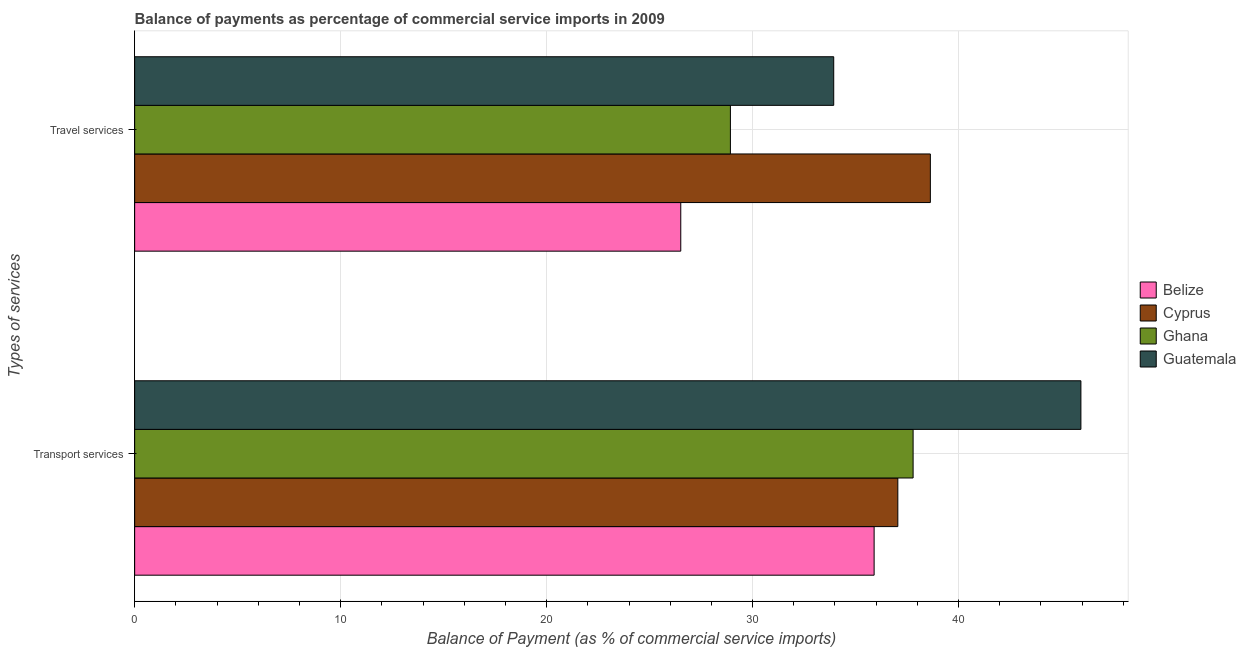Are the number of bars per tick equal to the number of legend labels?
Your answer should be very brief. Yes. Are the number of bars on each tick of the Y-axis equal?
Give a very brief answer. Yes. How many bars are there on the 1st tick from the bottom?
Offer a terse response. 4. What is the label of the 2nd group of bars from the top?
Your answer should be very brief. Transport services. What is the balance of payments of travel services in Guatemala?
Your response must be concise. 33.94. Across all countries, what is the maximum balance of payments of transport services?
Keep it short and to the point. 45.94. Across all countries, what is the minimum balance of payments of travel services?
Provide a succinct answer. 26.51. In which country was the balance of payments of transport services maximum?
Give a very brief answer. Guatemala. In which country was the balance of payments of transport services minimum?
Offer a very short reply. Belize. What is the total balance of payments of travel services in the graph?
Your response must be concise. 128.01. What is the difference between the balance of payments of transport services in Ghana and that in Belize?
Your answer should be very brief. 1.89. What is the difference between the balance of payments of travel services in Belize and the balance of payments of transport services in Cyprus?
Provide a succinct answer. -10.54. What is the average balance of payments of travel services per country?
Keep it short and to the point. 32. What is the difference between the balance of payments of transport services and balance of payments of travel services in Belize?
Your answer should be very brief. 9.39. What is the ratio of the balance of payments of travel services in Guatemala to that in Belize?
Your answer should be very brief. 1.28. What does the 3rd bar from the top in Transport services represents?
Keep it short and to the point. Cyprus. What does the 4th bar from the bottom in Travel services represents?
Offer a very short reply. Guatemala. Are all the bars in the graph horizontal?
Offer a terse response. Yes. How many countries are there in the graph?
Give a very brief answer. 4. Does the graph contain any zero values?
Your answer should be very brief. No. How many legend labels are there?
Ensure brevity in your answer.  4. What is the title of the graph?
Offer a terse response. Balance of payments as percentage of commercial service imports in 2009. Does "Afghanistan" appear as one of the legend labels in the graph?
Provide a short and direct response. No. What is the label or title of the X-axis?
Your response must be concise. Balance of Payment (as % of commercial service imports). What is the label or title of the Y-axis?
Your answer should be very brief. Types of services. What is the Balance of Payment (as % of commercial service imports) of Belize in Transport services?
Offer a very short reply. 35.9. What is the Balance of Payment (as % of commercial service imports) of Cyprus in Transport services?
Offer a terse response. 37.05. What is the Balance of Payment (as % of commercial service imports) of Ghana in Transport services?
Make the answer very short. 37.79. What is the Balance of Payment (as % of commercial service imports) of Guatemala in Transport services?
Keep it short and to the point. 45.94. What is the Balance of Payment (as % of commercial service imports) of Belize in Travel services?
Offer a terse response. 26.51. What is the Balance of Payment (as % of commercial service imports) of Cyprus in Travel services?
Provide a succinct answer. 38.63. What is the Balance of Payment (as % of commercial service imports) in Ghana in Travel services?
Your answer should be compact. 28.92. What is the Balance of Payment (as % of commercial service imports) in Guatemala in Travel services?
Offer a terse response. 33.94. Across all Types of services, what is the maximum Balance of Payment (as % of commercial service imports) of Belize?
Ensure brevity in your answer.  35.9. Across all Types of services, what is the maximum Balance of Payment (as % of commercial service imports) of Cyprus?
Offer a terse response. 38.63. Across all Types of services, what is the maximum Balance of Payment (as % of commercial service imports) of Ghana?
Provide a short and direct response. 37.79. Across all Types of services, what is the maximum Balance of Payment (as % of commercial service imports) in Guatemala?
Make the answer very short. 45.94. Across all Types of services, what is the minimum Balance of Payment (as % of commercial service imports) of Belize?
Make the answer very short. 26.51. Across all Types of services, what is the minimum Balance of Payment (as % of commercial service imports) in Cyprus?
Provide a short and direct response. 37.05. Across all Types of services, what is the minimum Balance of Payment (as % of commercial service imports) of Ghana?
Your answer should be very brief. 28.92. Across all Types of services, what is the minimum Balance of Payment (as % of commercial service imports) of Guatemala?
Your answer should be compact. 33.94. What is the total Balance of Payment (as % of commercial service imports) of Belize in the graph?
Ensure brevity in your answer.  62.41. What is the total Balance of Payment (as % of commercial service imports) of Cyprus in the graph?
Give a very brief answer. 75.68. What is the total Balance of Payment (as % of commercial service imports) in Ghana in the graph?
Provide a succinct answer. 66.72. What is the total Balance of Payment (as % of commercial service imports) in Guatemala in the graph?
Make the answer very short. 79.88. What is the difference between the Balance of Payment (as % of commercial service imports) in Belize in Transport services and that in Travel services?
Provide a short and direct response. 9.39. What is the difference between the Balance of Payment (as % of commercial service imports) in Cyprus in Transport services and that in Travel services?
Offer a terse response. -1.58. What is the difference between the Balance of Payment (as % of commercial service imports) in Ghana in Transport services and that in Travel services?
Your answer should be compact. 8.87. What is the difference between the Balance of Payment (as % of commercial service imports) of Guatemala in Transport services and that in Travel services?
Make the answer very short. 12. What is the difference between the Balance of Payment (as % of commercial service imports) of Belize in Transport services and the Balance of Payment (as % of commercial service imports) of Cyprus in Travel services?
Keep it short and to the point. -2.73. What is the difference between the Balance of Payment (as % of commercial service imports) in Belize in Transport services and the Balance of Payment (as % of commercial service imports) in Ghana in Travel services?
Offer a very short reply. 6.98. What is the difference between the Balance of Payment (as % of commercial service imports) in Belize in Transport services and the Balance of Payment (as % of commercial service imports) in Guatemala in Travel services?
Keep it short and to the point. 1.96. What is the difference between the Balance of Payment (as % of commercial service imports) in Cyprus in Transport services and the Balance of Payment (as % of commercial service imports) in Ghana in Travel services?
Make the answer very short. 8.13. What is the difference between the Balance of Payment (as % of commercial service imports) in Cyprus in Transport services and the Balance of Payment (as % of commercial service imports) in Guatemala in Travel services?
Make the answer very short. 3.11. What is the difference between the Balance of Payment (as % of commercial service imports) of Ghana in Transport services and the Balance of Payment (as % of commercial service imports) of Guatemala in Travel services?
Your response must be concise. 3.85. What is the average Balance of Payment (as % of commercial service imports) of Belize per Types of services?
Make the answer very short. 31.21. What is the average Balance of Payment (as % of commercial service imports) of Cyprus per Types of services?
Keep it short and to the point. 37.84. What is the average Balance of Payment (as % of commercial service imports) in Ghana per Types of services?
Ensure brevity in your answer.  33.36. What is the average Balance of Payment (as % of commercial service imports) in Guatemala per Types of services?
Make the answer very short. 39.94. What is the difference between the Balance of Payment (as % of commercial service imports) of Belize and Balance of Payment (as % of commercial service imports) of Cyprus in Transport services?
Offer a very short reply. -1.15. What is the difference between the Balance of Payment (as % of commercial service imports) of Belize and Balance of Payment (as % of commercial service imports) of Ghana in Transport services?
Keep it short and to the point. -1.89. What is the difference between the Balance of Payment (as % of commercial service imports) of Belize and Balance of Payment (as % of commercial service imports) of Guatemala in Transport services?
Make the answer very short. -10.04. What is the difference between the Balance of Payment (as % of commercial service imports) in Cyprus and Balance of Payment (as % of commercial service imports) in Ghana in Transport services?
Your answer should be very brief. -0.74. What is the difference between the Balance of Payment (as % of commercial service imports) in Cyprus and Balance of Payment (as % of commercial service imports) in Guatemala in Transport services?
Make the answer very short. -8.89. What is the difference between the Balance of Payment (as % of commercial service imports) of Ghana and Balance of Payment (as % of commercial service imports) of Guatemala in Transport services?
Your answer should be very brief. -8.15. What is the difference between the Balance of Payment (as % of commercial service imports) in Belize and Balance of Payment (as % of commercial service imports) in Cyprus in Travel services?
Offer a terse response. -12.12. What is the difference between the Balance of Payment (as % of commercial service imports) of Belize and Balance of Payment (as % of commercial service imports) of Ghana in Travel services?
Offer a terse response. -2.41. What is the difference between the Balance of Payment (as % of commercial service imports) of Belize and Balance of Payment (as % of commercial service imports) of Guatemala in Travel services?
Ensure brevity in your answer.  -7.43. What is the difference between the Balance of Payment (as % of commercial service imports) in Cyprus and Balance of Payment (as % of commercial service imports) in Ghana in Travel services?
Provide a short and direct response. 9.71. What is the difference between the Balance of Payment (as % of commercial service imports) in Cyprus and Balance of Payment (as % of commercial service imports) in Guatemala in Travel services?
Give a very brief answer. 4.69. What is the difference between the Balance of Payment (as % of commercial service imports) in Ghana and Balance of Payment (as % of commercial service imports) in Guatemala in Travel services?
Your answer should be compact. -5.02. What is the ratio of the Balance of Payment (as % of commercial service imports) of Belize in Transport services to that in Travel services?
Your answer should be compact. 1.35. What is the ratio of the Balance of Payment (as % of commercial service imports) in Cyprus in Transport services to that in Travel services?
Your answer should be compact. 0.96. What is the ratio of the Balance of Payment (as % of commercial service imports) in Ghana in Transport services to that in Travel services?
Ensure brevity in your answer.  1.31. What is the ratio of the Balance of Payment (as % of commercial service imports) of Guatemala in Transport services to that in Travel services?
Provide a succinct answer. 1.35. What is the difference between the highest and the second highest Balance of Payment (as % of commercial service imports) in Belize?
Your answer should be very brief. 9.39. What is the difference between the highest and the second highest Balance of Payment (as % of commercial service imports) of Cyprus?
Your response must be concise. 1.58. What is the difference between the highest and the second highest Balance of Payment (as % of commercial service imports) of Ghana?
Your answer should be compact. 8.87. What is the difference between the highest and the second highest Balance of Payment (as % of commercial service imports) in Guatemala?
Offer a very short reply. 12. What is the difference between the highest and the lowest Balance of Payment (as % of commercial service imports) in Belize?
Offer a very short reply. 9.39. What is the difference between the highest and the lowest Balance of Payment (as % of commercial service imports) of Cyprus?
Give a very brief answer. 1.58. What is the difference between the highest and the lowest Balance of Payment (as % of commercial service imports) of Ghana?
Provide a short and direct response. 8.87. What is the difference between the highest and the lowest Balance of Payment (as % of commercial service imports) of Guatemala?
Make the answer very short. 12. 